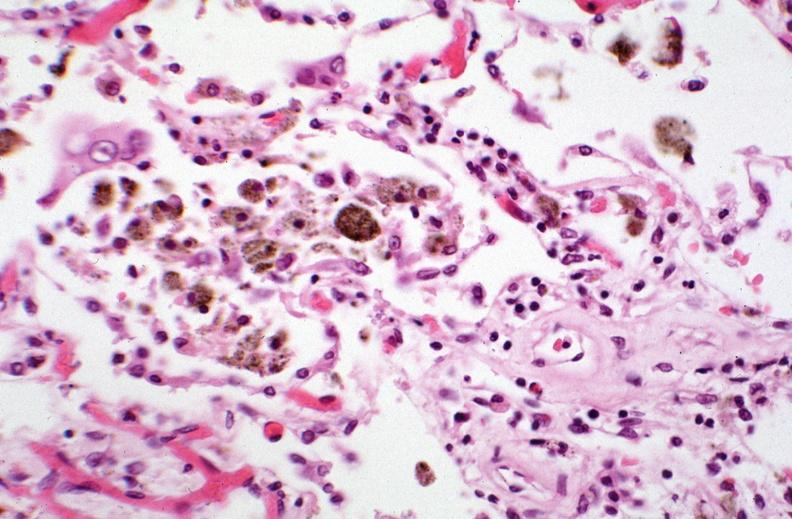how does this image show lung, pneumonia and hemosiderin laden macrophages in patient?
Answer the question using a single word or phrase. With sickle cell disease iatrogenic hemosiderosis 